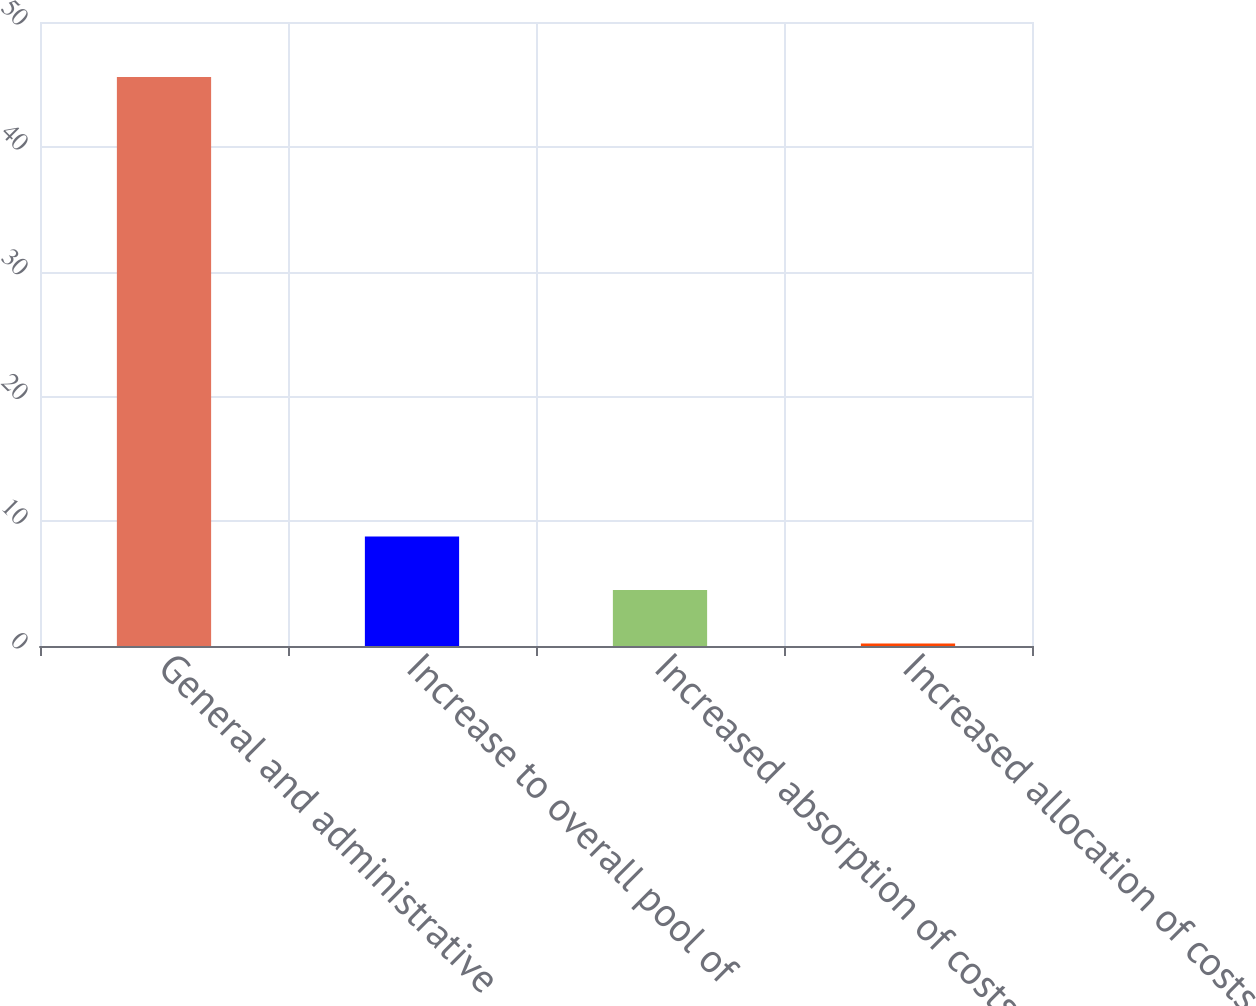Convert chart. <chart><loc_0><loc_0><loc_500><loc_500><bar_chart><fcel>General and administrative<fcel>Increase to overall pool of<fcel>Increased absorption of costs<fcel>Increased allocation of costs<nl><fcel>45.59<fcel>8.78<fcel>4.49<fcel>0.2<nl></chart> 